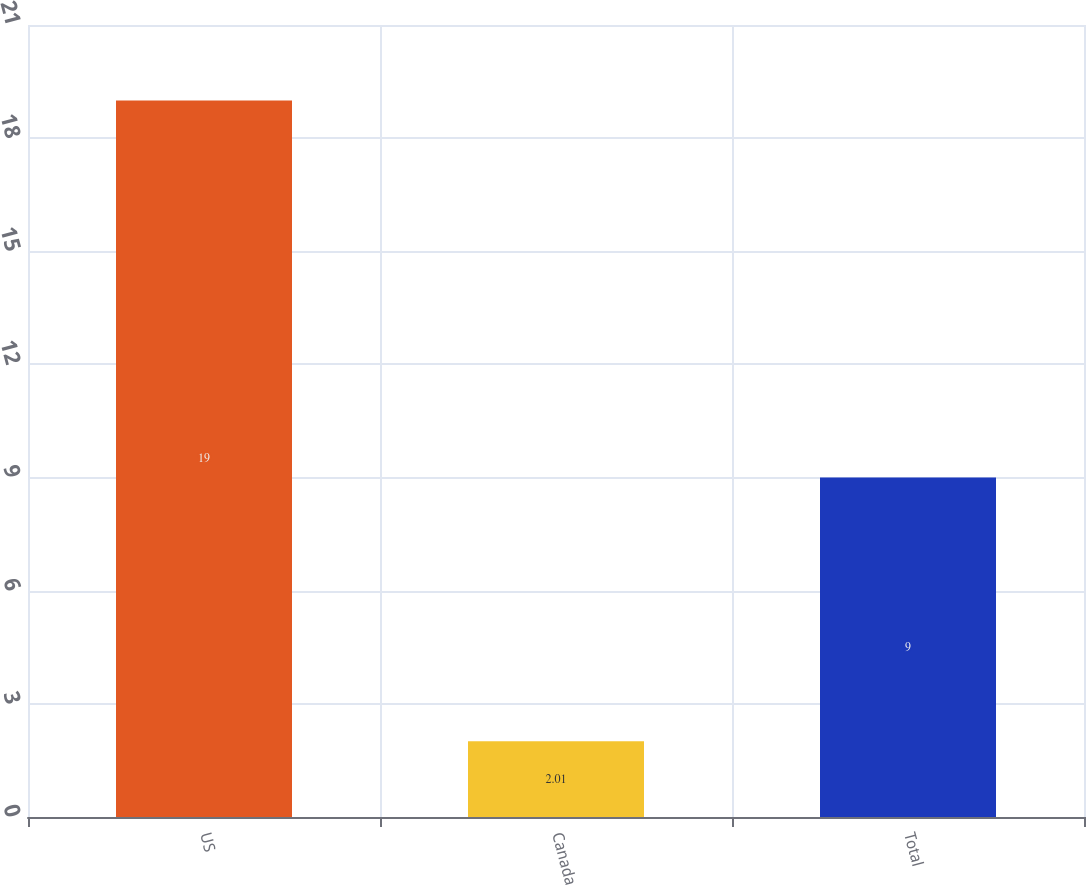Convert chart to OTSL. <chart><loc_0><loc_0><loc_500><loc_500><bar_chart><fcel>US<fcel>Canada<fcel>Total<nl><fcel>19<fcel>2.01<fcel>9<nl></chart> 